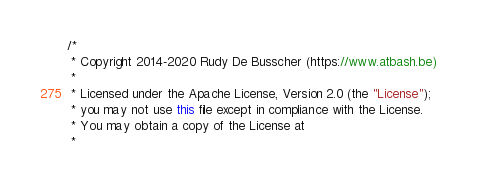Convert code to text. <code><loc_0><loc_0><loc_500><loc_500><_Java_>/*
 * Copyright 2014-2020 Rudy De Busscher (https://www.atbash.be)
 *
 * Licensed under the Apache License, Version 2.0 (the "License");
 * you may not use this file except in compliance with the License.
 * You may obtain a copy of the License at
 *</code> 